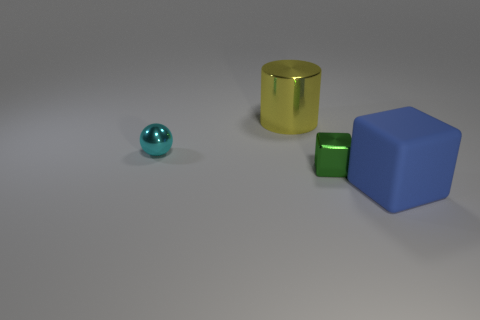Subtract all green cubes. How many cubes are left? 1 Subtract all balls. How many objects are left? 3 Add 2 metallic spheres. How many metallic spheres are left? 3 Add 2 big brown things. How many big brown things exist? 2 Add 1 shiny cylinders. How many objects exist? 5 Subtract 0 green cylinders. How many objects are left? 4 Subtract all green blocks. Subtract all yellow cylinders. How many blocks are left? 1 Subtract all brown spheres. How many blue blocks are left? 1 Subtract all tiny objects. Subtract all small spheres. How many objects are left? 1 